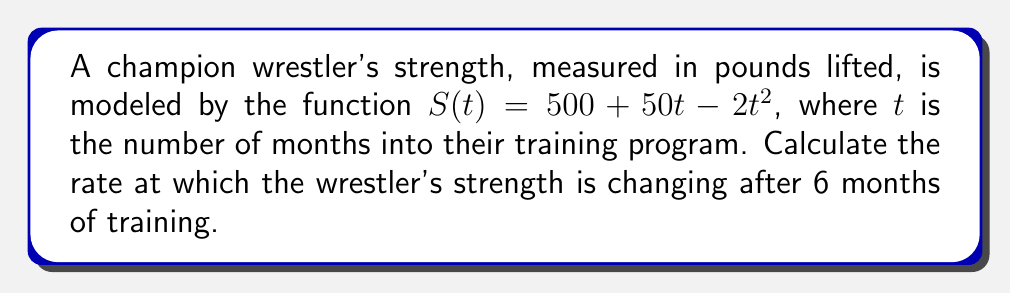Can you solve this math problem? To find the rate of change in the wrestler's strength at 6 months, we need to calculate the derivative of $S(t)$ and evaluate it at $t=6$. Let's follow these steps:

1) The given function is $S(t) = 500 + 50t - 2t^2$

2) To find the rate of change, we need to calculate $S'(t)$:
   $S'(t) = \frac{d}{dt}(500 + 50t - 2t^2)$
   $S'(t) = 0 + 50 - 4t$ (using the power rule)
   $S'(t) = 50 - 4t$

3) Now, we evaluate $S'(t)$ at $t=6$:
   $S'(6) = 50 - 4(6)$
   $S'(6) = 50 - 24$
   $S'(6) = 26$

The rate of change is measured in pounds per month, as $t$ is in months and $S(t)$ is in pounds.
Answer: 26 pounds per month 